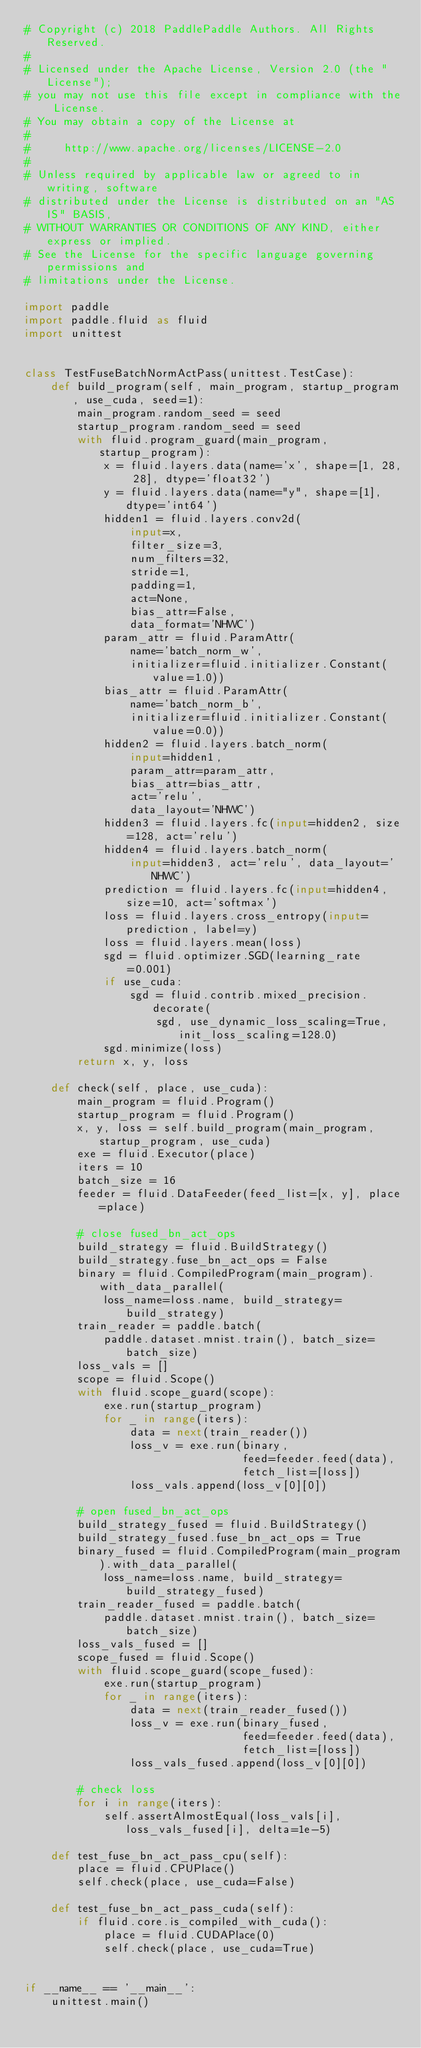Convert code to text. <code><loc_0><loc_0><loc_500><loc_500><_Python_># Copyright (c) 2018 PaddlePaddle Authors. All Rights Reserved.
#
# Licensed under the Apache License, Version 2.0 (the "License");
# you may not use this file except in compliance with the License.
# You may obtain a copy of the License at
#
#     http://www.apache.org/licenses/LICENSE-2.0
#
# Unless required by applicable law or agreed to in writing, software
# distributed under the License is distributed on an "AS IS" BASIS,
# WITHOUT WARRANTIES OR CONDITIONS OF ANY KIND, either express or implied.
# See the License for the specific language governing permissions and
# limitations under the License.

import paddle
import paddle.fluid as fluid
import unittest


class TestFuseBatchNormActPass(unittest.TestCase):
    def build_program(self, main_program, startup_program, use_cuda, seed=1):
        main_program.random_seed = seed
        startup_program.random_seed = seed
        with fluid.program_guard(main_program, startup_program):
            x = fluid.layers.data(name='x', shape=[1, 28, 28], dtype='float32')
            y = fluid.layers.data(name="y", shape=[1], dtype='int64')
            hidden1 = fluid.layers.conv2d(
                input=x,
                filter_size=3,
                num_filters=32,
                stride=1,
                padding=1,
                act=None,
                bias_attr=False,
                data_format='NHWC')
            param_attr = fluid.ParamAttr(
                name='batch_norm_w',
                initializer=fluid.initializer.Constant(value=1.0))
            bias_attr = fluid.ParamAttr(
                name='batch_norm_b',
                initializer=fluid.initializer.Constant(value=0.0))
            hidden2 = fluid.layers.batch_norm(
                input=hidden1,
                param_attr=param_attr,
                bias_attr=bias_attr,
                act='relu',
                data_layout='NHWC')
            hidden3 = fluid.layers.fc(input=hidden2, size=128, act='relu')
            hidden4 = fluid.layers.batch_norm(
                input=hidden3, act='relu', data_layout='NHWC')
            prediction = fluid.layers.fc(input=hidden4, size=10, act='softmax')
            loss = fluid.layers.cross_entropy(input=prediction, label=y)
            loss = fluid.layers.mean(loss)
            sgd = fluid.optimizer.SGD(learning_rate=0.001)
            if use_cuda:
                sgd = fluid.contrib.mixed_precision.decorate(
                    sgd, use_dynamic_loss_scaling=True, init_loss_scaling=128.0)
            sgd.minimize(loss)
        return x, y, loss

    def check(self, place, use_cuda):
        main_program = fluid.Program()
        startup_program = fluid.Program()
        x, y, loss = self.build_program(main_program, startup_program, use_cuda)
        exe = fluid.Executor(place)
        iters = 10
        batch_size = 16
        feeder = fluid.DataFeeder(feed_list=[x, y], place=place)

        # close fused_bn_act_ops
        build_strategy = fluid.BuildStrategy()
        build_strategy.fuse_bn_act_ops = False
        binary = fluid.CompiledProgram(main_program).with_data_parallel(
            loss_name=loss.name, build_strategy=build_strategy)
        train_reader = paddle.batch(
            paddle.dataset.mnist.train(), batch_size=batch_size)
        loss_vals = []
        scope = fluid.Scope()
        with fluid.scope_guard(scope):
            exe.run(startup_program)
            for _ in range(iters):
                data = next(train_reader())
                loss_v = exe.run(binary,
                                 feed=feeder.feed(data),
                                 fetch_list=[loss])
                loss_vals.append(loss_v[0][0])

        # open fused_bn_act_ops
        build_strategy_fused = fluid.BuildStrategy()
        build_strategy_fused.fuse_bn_act_ops = True
        binary_fused = fluid.CompiledProgram(main_program).with_data_parallel(
            loss_name=loss.name, build_strategy=build_strategy_fused)
        train_reader_fused = paddle.batch(
            paddle.dataset.mnist.train(), batch_size=batch_size)
        loss_vals_fused = []
        scope_fused = fluid.Scope()
        with fluid.scope_guard(scope_fused):
            exe.run(startup_program)
            for _ in range(iters):
                data = next(train_reader_fused())
                loss_v = exe.run(binary_fused,
                                 feed=feeder.feed(data),
                                 fetch_list=[loss])
                loss_vals_fused.append(loss_v[0][0])

        # check loss
        for i in range(iters):
            self.assertAlmostEqual(loss_vals[i], loss_vals_fused[i], delta=1e-5)

    def test_fuse_bn_act_pass_cpu(self):
        place = fluid.CPUPlace()
        self.check(place, use_cuda=False)

    def test_fuse_bn_act_pass_cuda(self):
        if fluid.core.is_compiled_with_cuda():
            place = fluid.CUDAPlace(0)
            self.check(place, use_cuda=True)


if __name__ == '__main__':
    unittest.main()
</code> 